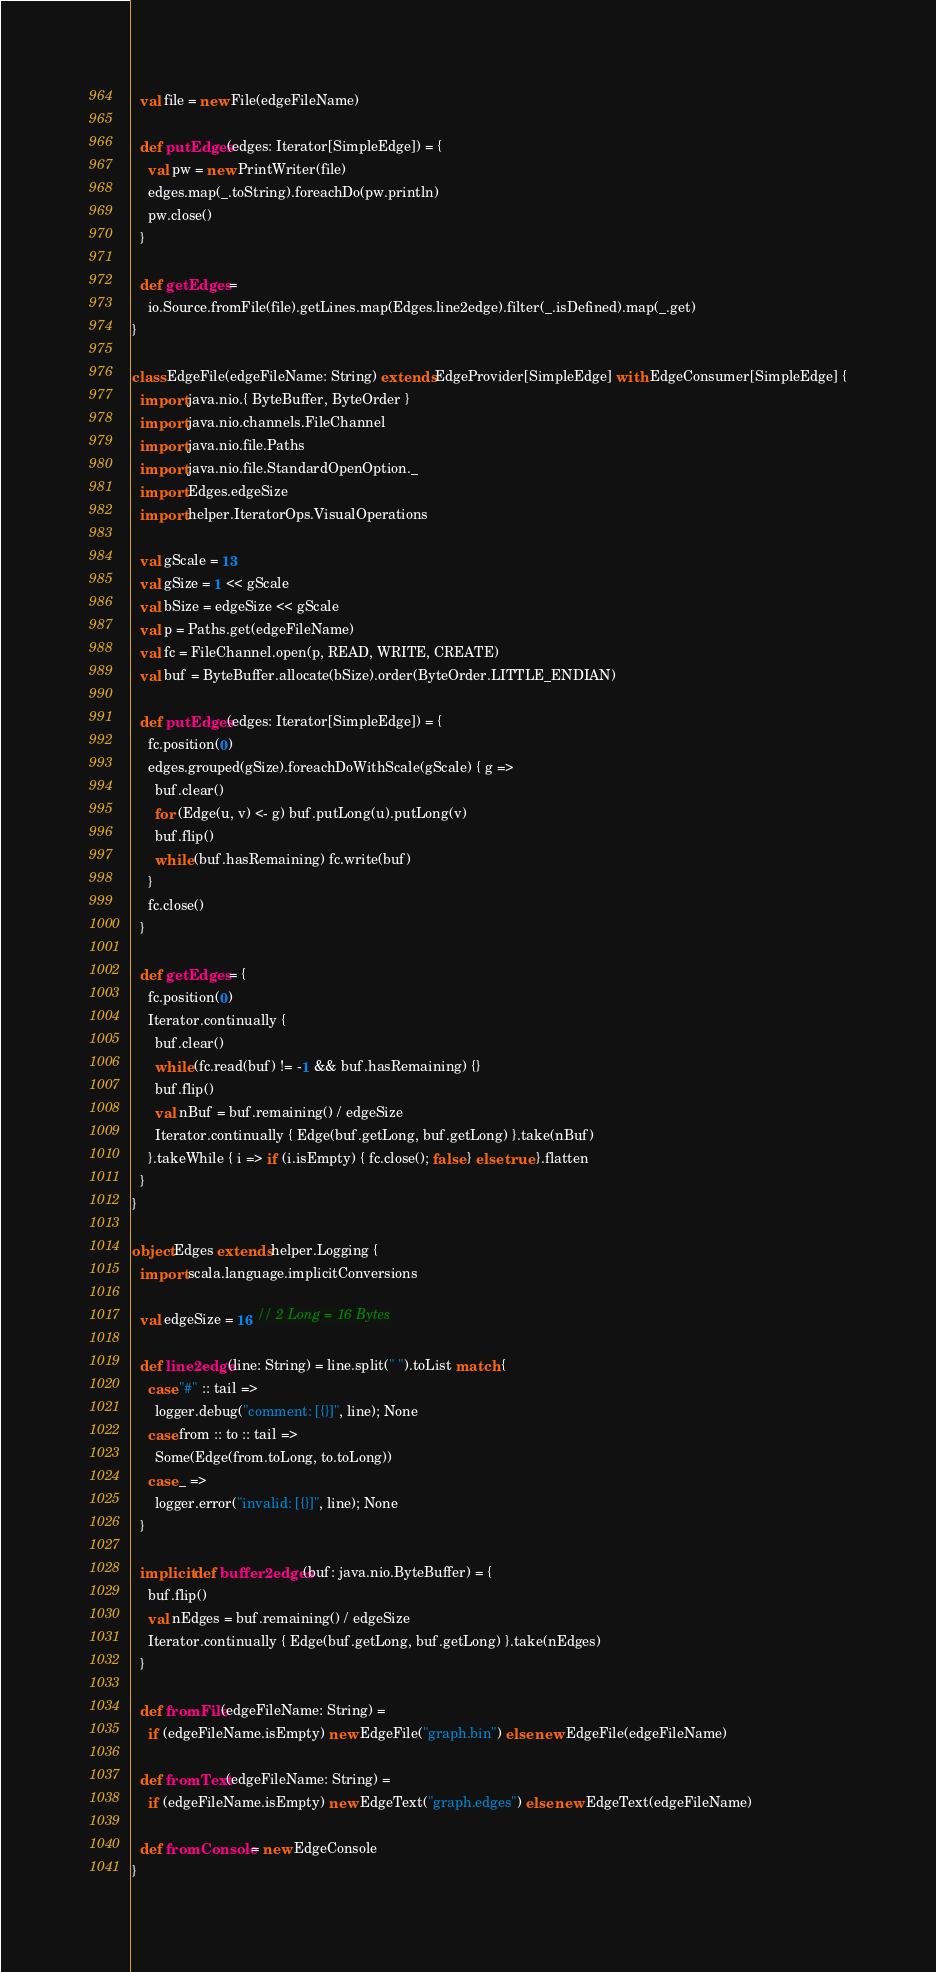Convert code to text. <code><loc_0><loc_0><loc_500><loc_500><_Scala_>
  val file = new File(edgeFileName)

  def putEdges(edges: Iterator[SimpleEdge]) = {
    val pw = new PrintWriter(file)
    edges.map(_.toString).foreachDo(pw.println)
    pw.close()
  }

  def getEdges =
    io.Source.fromFile(file).getLines.map(Edges.line2edge).filter(_.isDefined).map(_.get)
}

class EdgeFile(edgeFileName: String) extends EdgeProvider[SimpleEdge] with EdgeConsumer[SimpleEdge] {
  import java.nio.{ ByteBuffer, ByteOrder }
  import java.nio.channels.FileChannel
  import java.nio.file.Paths
  import java.nio.file.StandardOpenOption._
  import Edges.edgeSize
  import helper.IteratorOps.VisualOperations

  val gScale = 13
  val gSize = 1 << gScale
  val bSize = edgeSize << gScale
  val p = Paths.get(edgeFileName)
  val fc = FileChannel.open(p, READ, WRITE, CREATE)
  val buf = ByteBuffer.allocate(bSize).order(ByteOrder.LITTLE_ENDIAN)

  def putEdges(edges: Iterator[SimpleEdge]) = {
    fc.position(0)
    edges.grouped(gSize).foreachDoWithScale(gScale) { g =>
      buf.clear()
      for (Edge(u, v) <- g) buf.putLong(u).putLong(v)
      buf.flip()
      while (buf.hasRemaining) fc.write(buf)
    }
    fc.close()
  }

  def getEdges = {
    fc.position(0)
    Iterator.continually {
      buf.clear()
      while (fc.read(buf) != -1 && buf.hasRemaining) {}
      buf.flip()
      val nBuf = buf.remaining() / edgeSize
      Iterator.continually { Edge(buf.getLong, buf.getLong) }.take(nBuf)
    }.takeWhile { i => if (i.isEmpty) { fc.close(); false } else true }.flatten
  }
}

object Edges extends helper.Logging {
  import scala.language.implicitConversions

  val edgeSize = 16 // 2 Long = 16 Bytes

  def line2edge(line: String) = line.split(" ").toList match {
    case "#" :: tail =>
      logger.debug("comment: [{}]", line); None
    case from :: to :: tail =>
      Some(Edge(from.toLong, to.toLong))
    case _ =>
      logger.error("invalid: [{}]", line); None
  }

  implicit def buffer2edges(buf: java.nio.ByteBuffer) = {
    buf.flip()
    val nEdges = buf.remaining() / edgeSize
    Iterator.continually { Edge(buf.getLong, buf.getLong) }.take(nEdges)
  }

  def fromFile(edgeFileName: String) =
    if (edgeFileName.isEmpty) new EdgeFile("graph.bin") else new EdgeFile(edgeFileName)

  def fromText(edgeFileName: String) =
    if (edgeFileName.isEmpty) new EdgeText("graph.edges") else new EdgeText(edgeFileName)

  def fromConsole = new EdgeConsole
}
</code> 